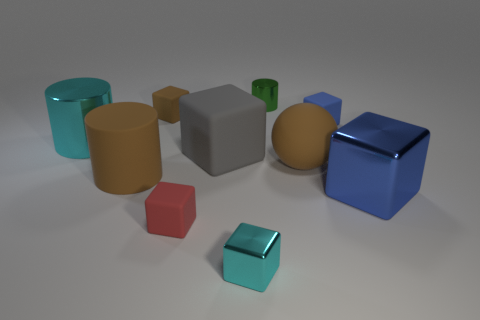The ball that is the same color as the large matte cylinder is what size?
Your answer should be very brief. Large. There is a small matte object that is to the right of the small green metallic cylinder; does it have the same shape as the green thing?
Provide a succinct answer. No. What material is the big blue object that is the same shape as the gray matte thing?
Ensure brevity in your answer.  Metal. How many brown cubes are the same size as the cyan block?
Ensure brevity in your answer.  1. The tiny matte thing that is behind the large cyan cylinder and on the left side of the tiny cyan metallic object is what color?
Give a very brief answer. Brown. Is the number of large red shiny cubes less than the number of red cubes?
Your answer should be compact. Yes. Do the small metallic cube and the big cube left of the blue metallic cube have the same color?
Provide a succinct answer. No. Are there the same number of green things in front of the red rubber block and large metallic objects on the left side of the big metal block?
Offer a terse response. No. What number of cyan objects have the same shape as the blue rubber thing?
Give a very brief answer. 1. Is there a blue object?
Your answer should be compact. Yes. 